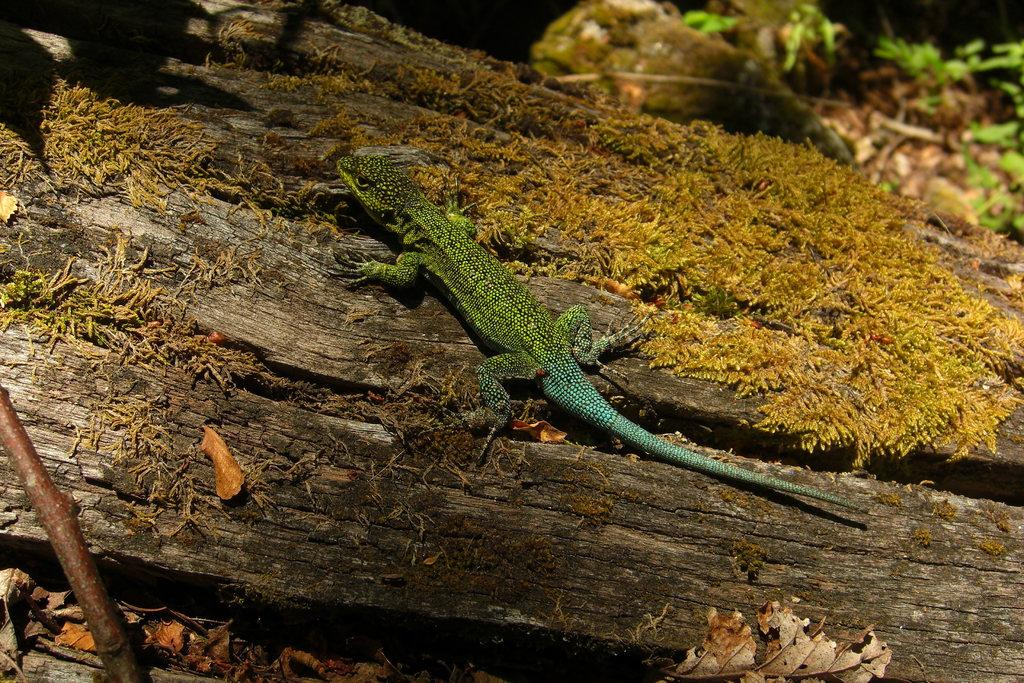What type of animal is in the image? There is a reptile in the image. Where is the reptile located? The reptile is on a wooden log. What other natural elements can be seen in the image? Dry leaves are present in the image. Is there any part of the image that is not clear? Yes, the image is slightly blurred in a specific part. How many eggs does the reptile have in the image? There is no indication of eggs in the image; it only shows a reptile on a wooden log and dry leaves. 